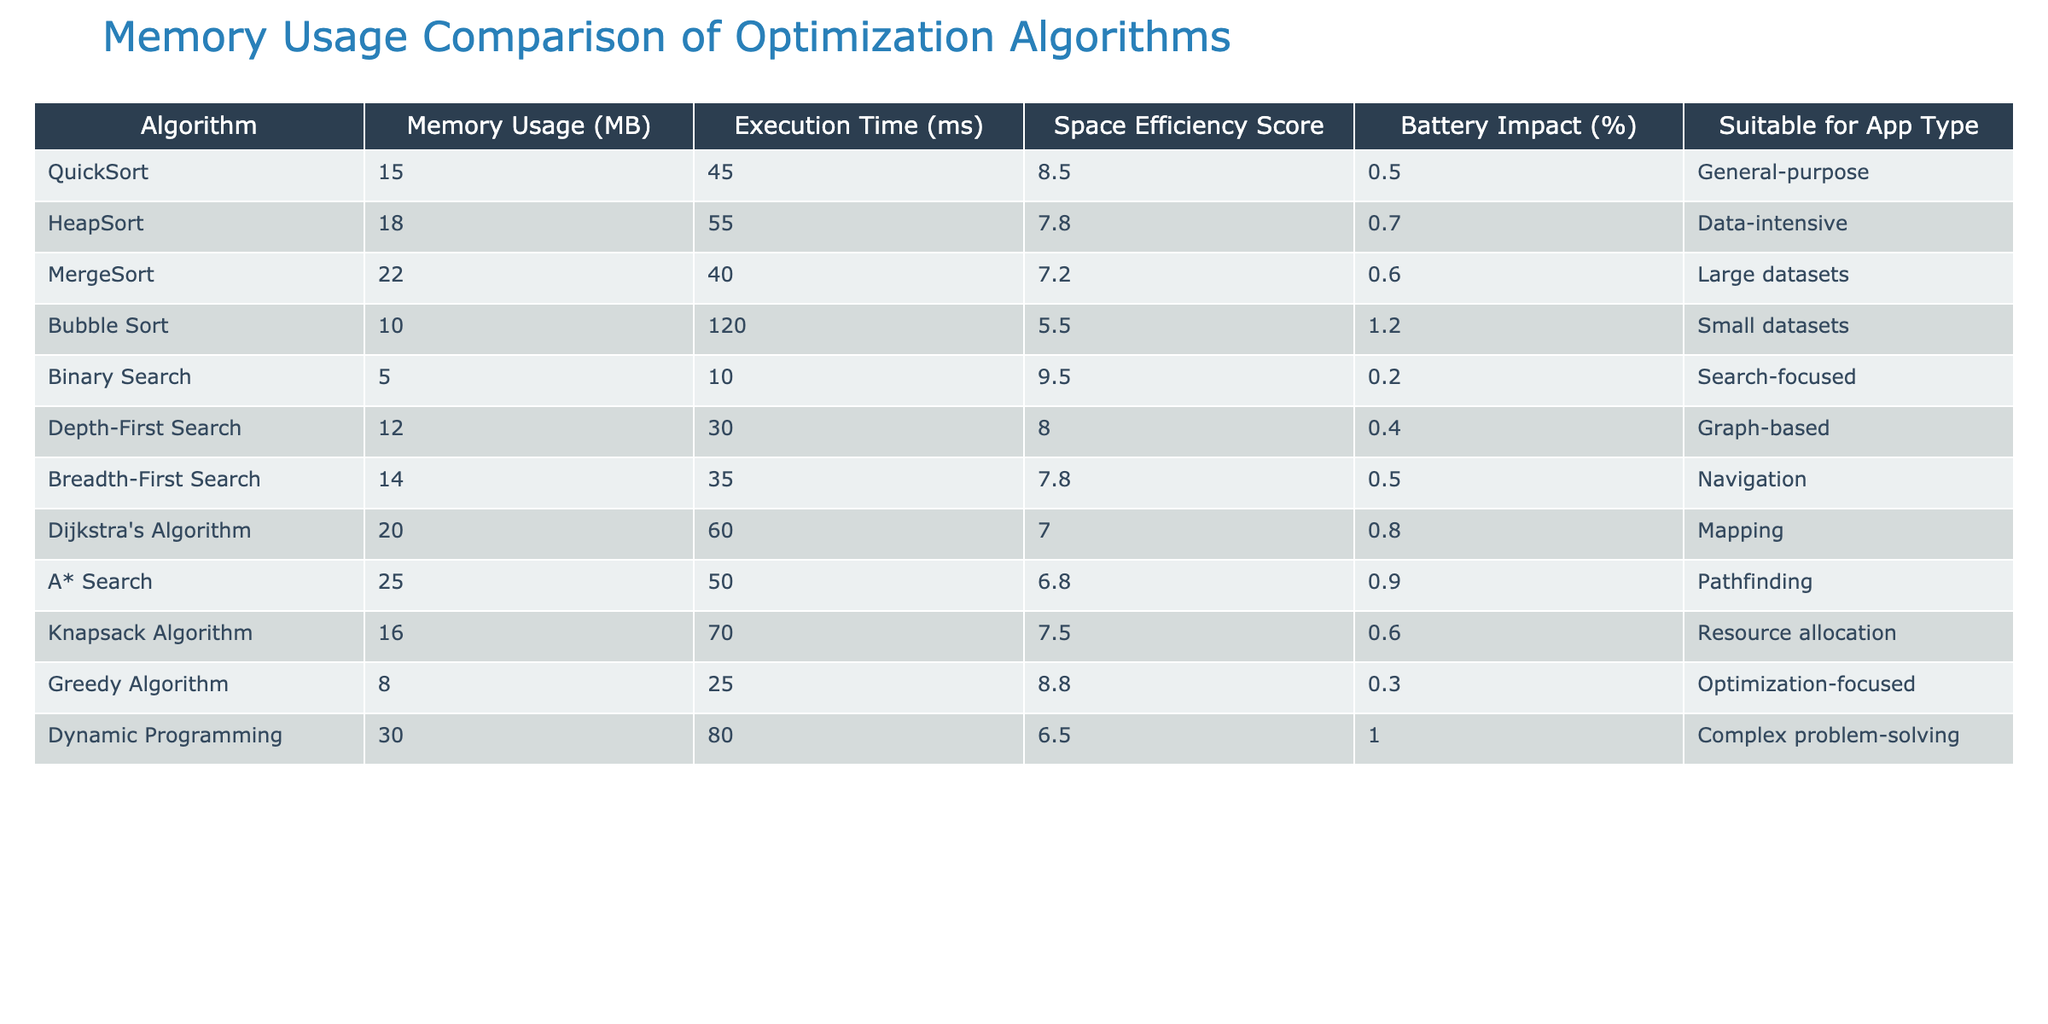What is the memory usage of Bubble Sort? The table shows that Bubble Sort has a memory usage of 10 MB listed under the "Memory Usage (MB)" column.
Answer: 10 MB Which algorithm has the highest execution time? Examining the "Execution Time (ms)" column, Dynamic Programming has the highest value at 80 ms.
Answer: Dynamic Programming Is A* Search suitable for data-intensive applications? The table indicates that A* Search is identified for "Pathfinding," not for data-intensive applications, as HeapSort is designated with that suitability.
Answer: No What is the difference in memory usage between QuickSort and HeapSort? QuickSort has a memory usage of 15 MB and HeapSort has 18 MB, so the difference is 18 - 15 = 3 MB.
Answer: 3 MB Which algorithm has the best space efficiency score, and what is that score? Looking at the "Space Efficiency Score" column, Binary Search has the best score of 9.5.
Answer: Binary Search, 9.5 What is the average execution time of the algorithms that are suitable for "Search-focused" applications? The only algorithm suited for "Search-focused" applications is Binary Search, which has an execution time of 10 ms, so the average is also 10 ms.
Answer: 10 ms Is there any algorithm with memory usage below 10 MB? The table shows that Binary Search has a memory usage of 5 MB, which is below 10 MB.
Answer: Yes Which algorithm is least battery-impacting based on the provided data? By reviewing the "Battery Impact (%)" column, Greedy Algorithm has the least impact at 0.3%.
Answer: Greedy Algorithm, 0.3% How many algorithms have a memory usage greater than 20 MB? The algorithms with memory usage greater than 20 MB are MergeSort, A* Search, and Dynamic Programming, which totals to three algorithms.
Answer: 3 What is the combined memory usage of the algorithms suitable for resource allocation and complex problem-solving? The Knapsack Algorithm for resource allocation uses 16 MB, and Dynamic Programming for complex problem-solving uses 30 MB; the combined memory usage is 16 + 30 = 46 MB.
Answer: 46 MB 